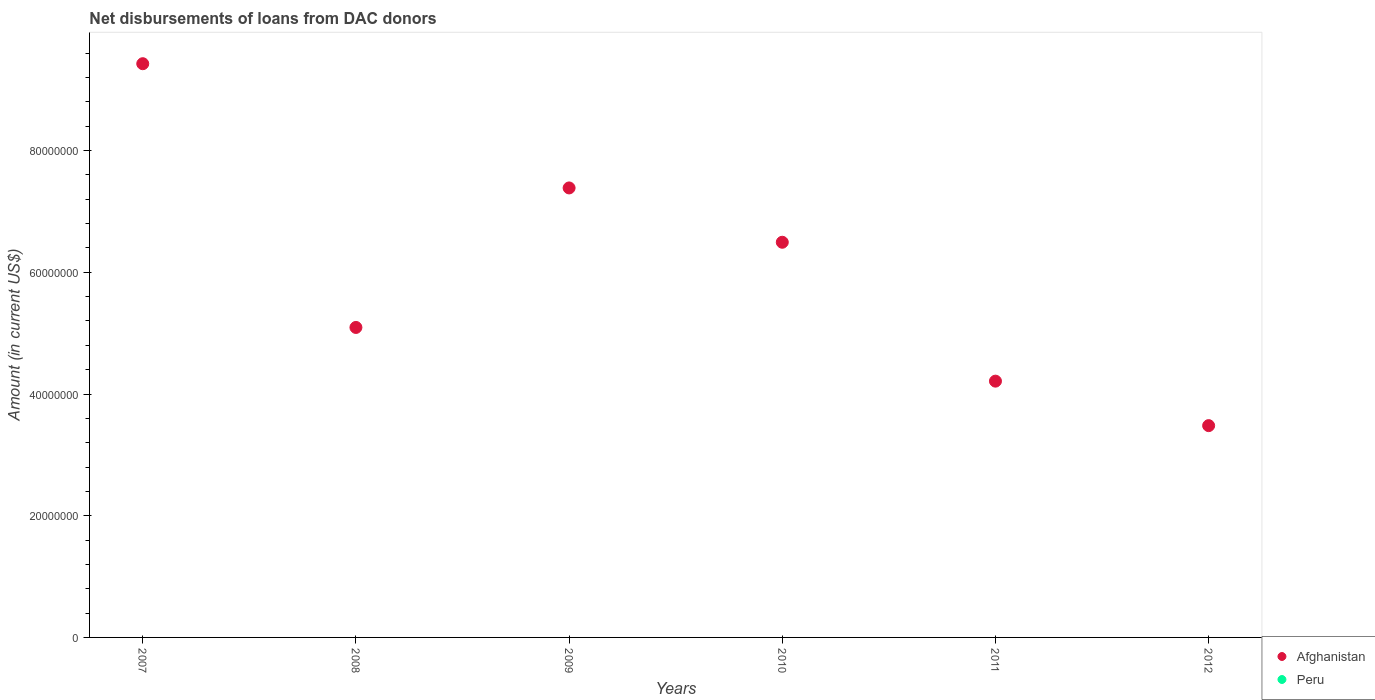What is the amount of loans disbursed in Afghanistan in 2012?
Ensure brevity in your answer.  3.48e+07. Across all years, what is the minimum amount of loans disbursed in Afghanistan?
Your response must be concise. 3.48e+07. What is the total amount of loans disbursed in Peru in the graph?
Provide a succinct answer. 0. What is the difference between the amount of loans disbursed in Afghanistan in 2009 and that in 2011?
Give a very brief answer. 3.17e+07. What is the difference between the amount of loans disbursed in Peru in 2009 and the amount of loans disbursed in Afghanistan in 2010?
Give a very brief answer. -6.49e+07. What is the ratio of the amount of loans disbursed in Afghanistan in 2007 to that in 2012?
Provide a succinct answer. 2.71. Is the amount of loans disbursed in Afghanistan in 2007 less than that in 2011?
Give a very brief answer. No. What is the difference between the highest and the second highest amount of loans disbursed in Afghanistan?
Your answer should be very brief. 2.04e+07. What is the difference between the highest and the lowest amount of loans disbursed in Afghanistan?
Make the answer very short. 5.95e+07. In how many years, is the amount of loans disbursed in Peru greater than the average amount of loans disbursed in Peru taken over all years?
Keep it short and to the point. 0. Does the amount of loans disbursed in Peru monotonically increase over the years?
Ensure brevity in your answer.  No. Is the amount of loans disbursed in Afghanistan strictly less than the amount of loans disbursed in Peru over the years?
Keep it short and to the point. No. How many dotlines are there?
Offer a very short reply. 1. Are the values on the major ticks of Y-axis written in scientific E-notation?
Offer a terse response. No. Does the graph contain grids?
Ensure brevity in your answer.  No. How are the legend labels stacked?
Give a very brief answer. Vertical. What is the title of the graph?
Make the answer very short. Net disbursements of loans from DAC donors. Does "Sweden" appear as one of the legend labels in the graph?
Offer a very short reply. No. What is the label or title of the X-axis?
Ensure brevity in your answer.  Years. What is the Amount (in current US$) of Afghanistan in 2007?
Give a very brief answer. 9.43e+07. What is the Amount (in current US$) in Afghanistan in 2008?
Provide a succinct answer. 5.09e+07. What is the Amount (in current US$) in Peru in 2008?
Your response must be concise. 0. What is the Amount (in current US$) in Afghanistan in 2009?
Offer a very short reply. 7.39e+07. What is the Amount (in current US$) in Afghanistan in 2010?
Your answer should be compact. 6.49e+07. What is the Amount (in current US$) in Afghanistan in 2011?
Provide a succinct answer. 4.21e+07. What is the Amount (in current US$) in Peru in 2011?
Provide a short and direct response. 0. What is the Amount (in current US$) of Afghanistan in 2012?
Provide a succinct answer. 3.48e+07. What is the Amount (in current US$) of Peru in 2012?
Provide a short and direct response. 0. Across all years, what is the maximum Amount (in current US$) of Afghanistan?
Your answer should be compact. 9.43e+07. Across all years, what is the minimum Amount (in current US$) of Afghanistan?
Provide a short and direct response. 3.48e+07. What is the total Amount (in current US$) of Afghanistan in the graph?
Give a very brief answer. 3.61e+08. What is the total Amount (in current US$) of Peru in the graph?
Your answer should be compact. 0. What is the difference between the Amount (in current US$) of Afghanistan in 2007 and that in 2008?
Provide a succinct answer. 4.33e+07. What is the difference between the Amount (in current US$) in Afghanistan in 2007 and that in 2009?
Provide a short and direct response. 2.04e+07. What is the difference between the Amount (in current US$) of Afghanistan in 2007 and that in 2010?
Keep it short and to the point. 2.93e+07. What is the difference between the Amount (in current US$) of Afghanistan in 2007 and that in 2011?
Your answer should be compact. 5.22e+07. What is the difference between the Amount (in current US$) of Afghanistan in 2007 and that in 2012?
Keep it short and to the point. 5.95e+07. What is the difference between the Amount (in current US$) in Afghanistan in 2008 and that in 2009?
Offer a terse response. -2.29e+07. What is the difference between the Amount (in current US$) of Afghanistan in 2008 and that in 2010?
Your answer should be very brief. -1.40e+07. What is the difference between the Amount (in current US$) in Afghanistan in 2008 and that in 2011?
Your answer should be very brief. 8.82e+06. What is the difference between the Amount (in current US$) of Afghanistan in 2008 and that in 2012?
Your response must be concise. 1.61e+07. What is the difference between the Amount (in current US$) of Afghanistan in 2009 and that in 2010?
Provide a succinct answer. 8.93e+06. What is the difference between the Amount (in current US$) in Afghanistan in 2009 and that in 2011?
Your response must be concise. 3.17e+07. What is the difference between the Amount (in current US$) in Afghanistan in 2009 and that in 2012?
Give a very brief answer. 3.91e+07. What is the difference between the Amount (in current US$) in Afghanistan in 2010 and that in 2011?
Offer a very short reply. 2.28e+07. What is the difference between the Amount (in current US$) in Afghanistan in 2010 and that in 2012?
Your answer should be compact. 3.01e+07. What is the difference between the Amount (in current US$) in Afghanistan in 2011 and that in 2012?
Provide a succinct answer. 7.31e+06. What is the average Amount (in current US$) in Afghanistan per year?
Provide a succinct answer. 6.02e+07. What is the ratio of the Amount (in current US$) of Afghanistan in 2007 to that in 2008?
Your response must be concise. 1.85. What is the ratio of the Amount (in current US$) in Afghanistan in 2007 to that in 2009?
Your response must be concise. 1.28. What is the ratio of the Amount (in current US$) in Afghanistan in 2007 to that in 2010?
Offer a terse response. 1.45. What is the ratio of the Amount (in current US$) in Afghanistan in 2007 to that in 2011?
Your response must be concise. 2.24. What is the ratio of the Amount (in current US$) in Afghanistan in 2007 to that in 2012?
Make the answer very short. 2.71. What is the ratio of the Amount (in current US$) in Afghanistan in 2008 to that in 2009?
Provide a succinct answer. 0.69. What is the ratio of the Amount (in current US$) of Afghanistan in 2008 to that in 2010?
Offer a very short reply. 0.78. What is the ratio of the Amount (in current US$) of Afghanistan in 2008 to that in 2011?
Keep it short and to the point. 1.21. What is the ratio of the Amount (in current US$) in Afghanistan in 2008 to that in 2012?
Make the answer very short. 1.46. What is the ratio of the Amount (in current US$) of Afghanistan in 2009 to that in 2010?
Your answer should be very brief. 1.14. What is the ratio of the Amount (in current US$) of Afghanistan in 2009 to that in 2011?
Your answer should be very brief. 1.75. What is the ratio of the Amount (in current US$) of Afghanistan in 2009 to that in 2012?
Your answer should be compact. 2.12. What is the ratio of the Amount (in current US$) in Afghanistan in 2010 to that in 2011?
Keep it short and to the point. 1.54. What is the ratio of the Amount (in current US$) in Afghanistan in 2010 to that in 2012?
Offer a very short reply. 1.87. What is the ratio of the Amount (in current US$) of Afghanistan in 2011 to that in 2012?
Keep it short and to the point. 1.21. What is the difference between the highest and the second highest Amount (in current US$) of Afghanistan?
Your response must be concise. 2.04e+07. What is the difference between the highest and the lowest Amount (in current US$) in Afghanistan?
Make the answer very short. 5.95e+07. 